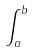<formula> <loc_0><loc_0><loc_500><loc_500>\int _ { a } ^ { b }</formula> 